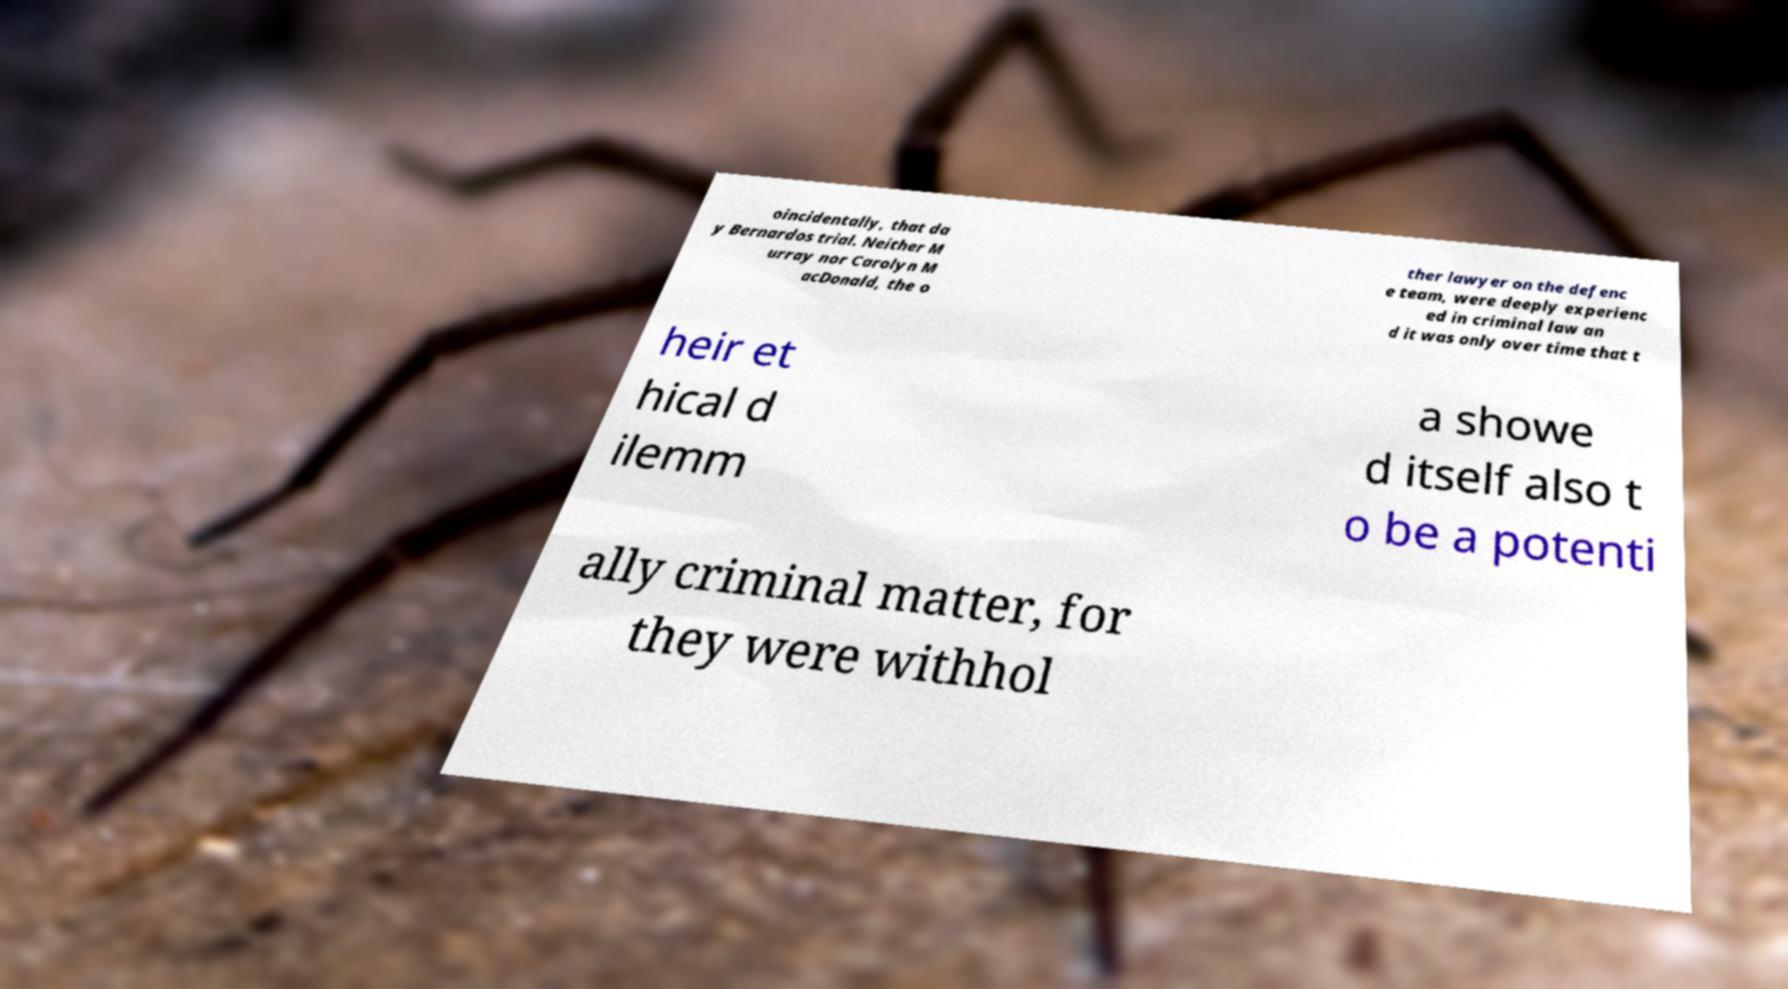There's text embedded in this image that I need extracted. Can you transcribe it verbatim? oincidentally, that da y Bernardos trial. Neither M urray nor Carolyn M acDonald, the o ther lawyer on the defenc e team, were deeply experienc ed in criminal law an d it was only over time that t heir et hical d ilemm a showe d itself also t o be a potenti ally criminal matter, for they were withhol 